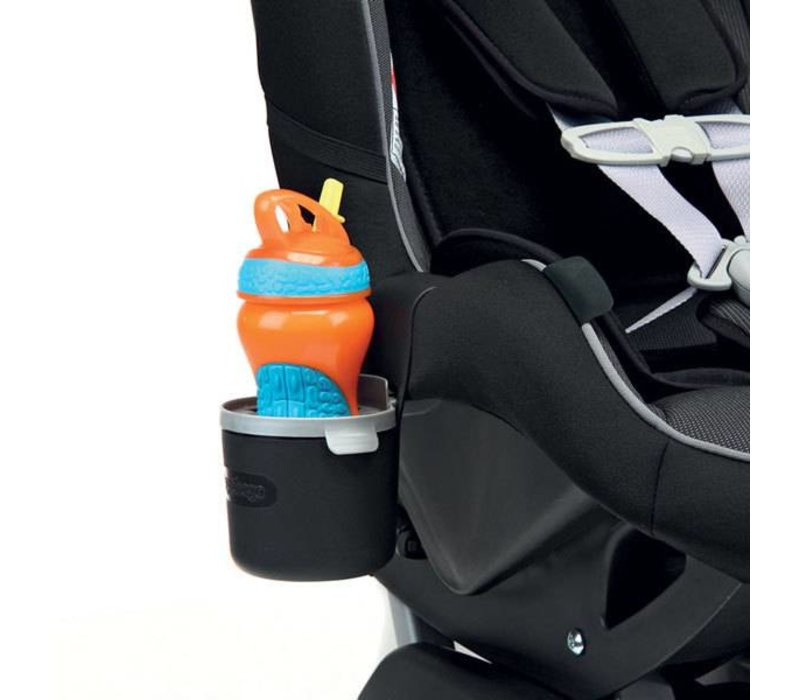How does the design of the drink holder contribute to the overall functionality of the car seat? The drink holder’s strategic placement not only makes it easy for a child to independently reach for their drink but also aids in maintaining a tidy space by containing spills within an easily cleanable area. This design choice enhances functionality by promoting autonomy in young passengers and simplifying maintenance for caregivers. 